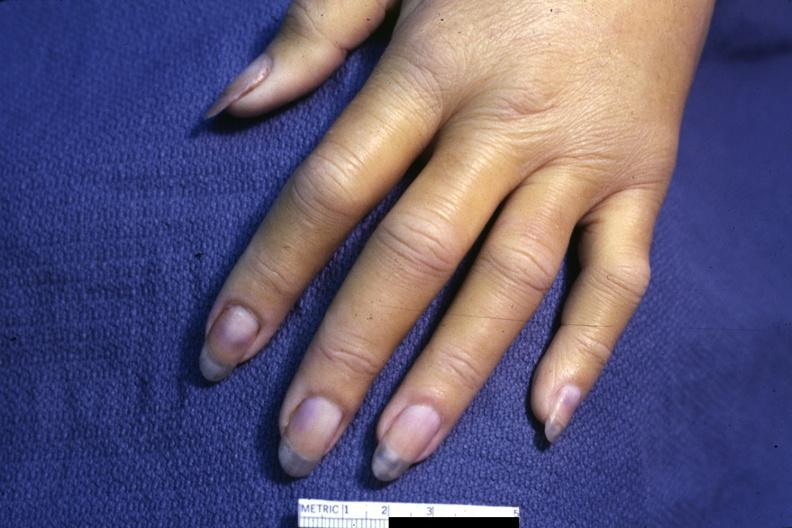re hyalin mass in pituitary which is amyloid there are several slides from this case in this file 23 yowf amyloid limited to brain present?
Answer the question using a single word or phrase. No 